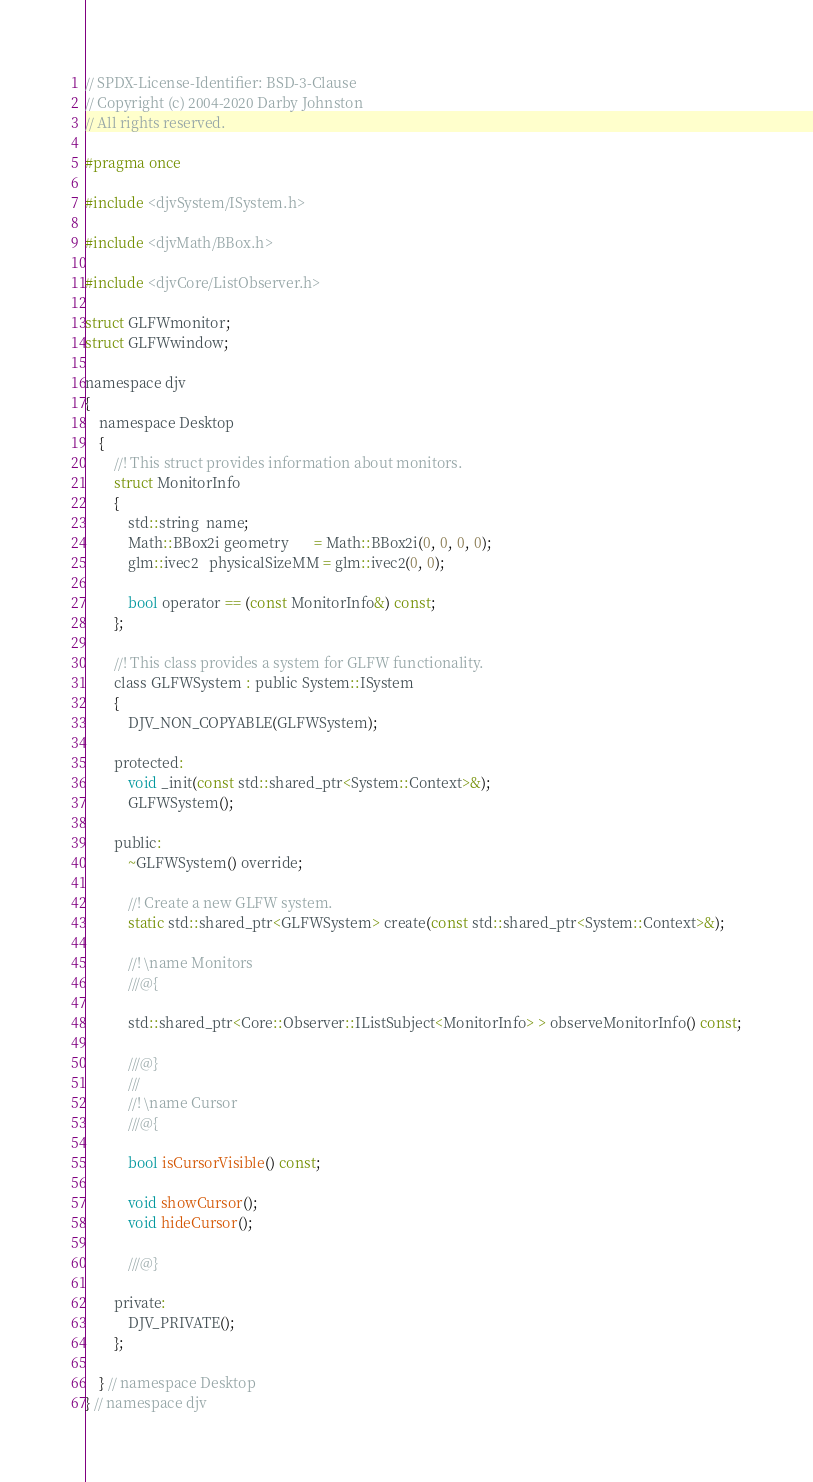<code> <loc_0><loc_0><loc_500><loc_500><_C_>// SPDX-License-Identifier: BSD-3-Clause
// Copyright (c) 2004-2020 Darby Johnston
// All rights reserved.

#pragma once

#include <djvSystem/ISystem.h>

#include <djvMath/BBox.h>

#include <djvCore/ListObserver.h>

struct GLFWmonitor;
struct GLFWwindow;

namespace djv
{
    namespace Desktop
    {
        //! This struct provides information about monitors.
        struct MonitorInfo
        {
            std::string  name;
            Math::BBox2i geometry       = Math::BBox2i(0, 0, 0, 0);
            glm::ivec2   physicalSizeMM = glm::ivec2(0, 0);

            bool operator == (const MonitorInfo&) const;
        };

        //! This class provides a system for GLFW functionality.
        class GLFWSystem : public System::ISystem
        {
            DJV_NON_COPYABLE(GLFWSystem);
            
        protected:
            void _init(const std::shared_ptr<System::Context>&);
            GLFWSystem();

        public:
            ~GLFWSystem() override;
            
            //! Create a new GLFW system.
            static std::shared_ptr<GLFWSystem> create(const std::shared_ptr<System::Context>&);

            //! \name Monitors
            ///@{

            std::shared_ptr<Core::Observer::IListSubject<MonitorInfo> > observeMonitorInfo() const;

            ///@}
            /// 
            //! \name Cursor
            ///@{

            bool isCursorVisible() const;

            void showCursor();
            void hideCursor();

            ///@}

        private:
            DJV_PRIVATE();
        };

    } // namespace Desktop
} // namespace djv
</code> 